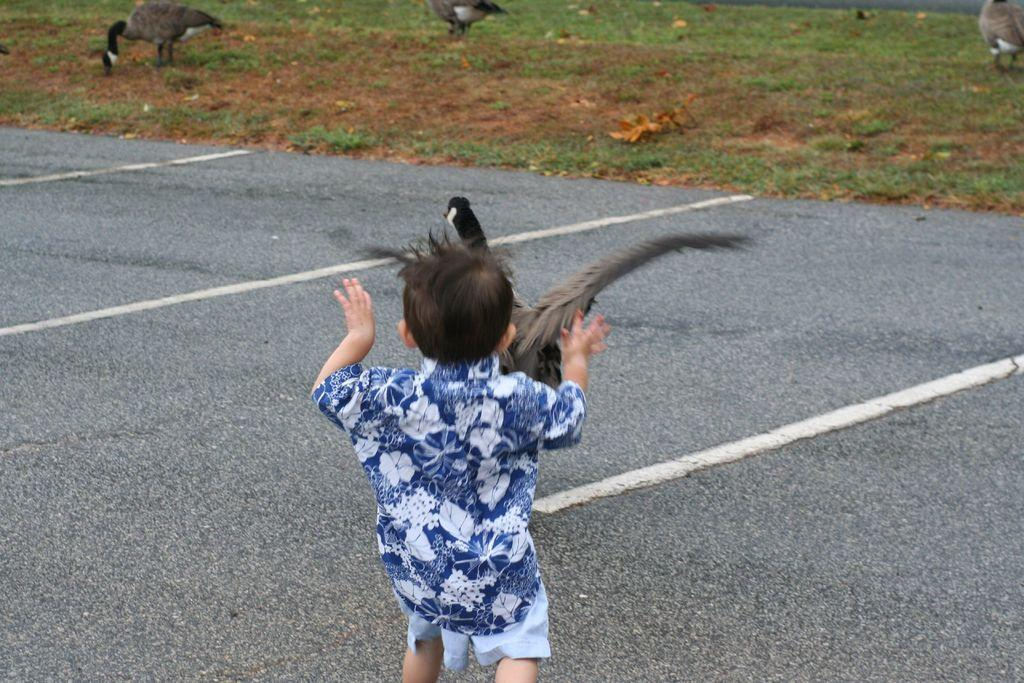Who is present in the image? There is a boy in the image. What is the boy doing in the image? The boy is playing with a bird. Where is the boy located in the image? The boy is on the road. What can be seen at the top of the image? The image shows an open garden at the top. What type of vegetation is present in the garden? There is grass in the garden. What other living creatures can be seen in the garden? There are birds in the garden. What type of tank can be seen in the image? There is no tank present in the image. What toys is the boy playing with in the image? The boy is playing with a bird, not toys, in the image. 